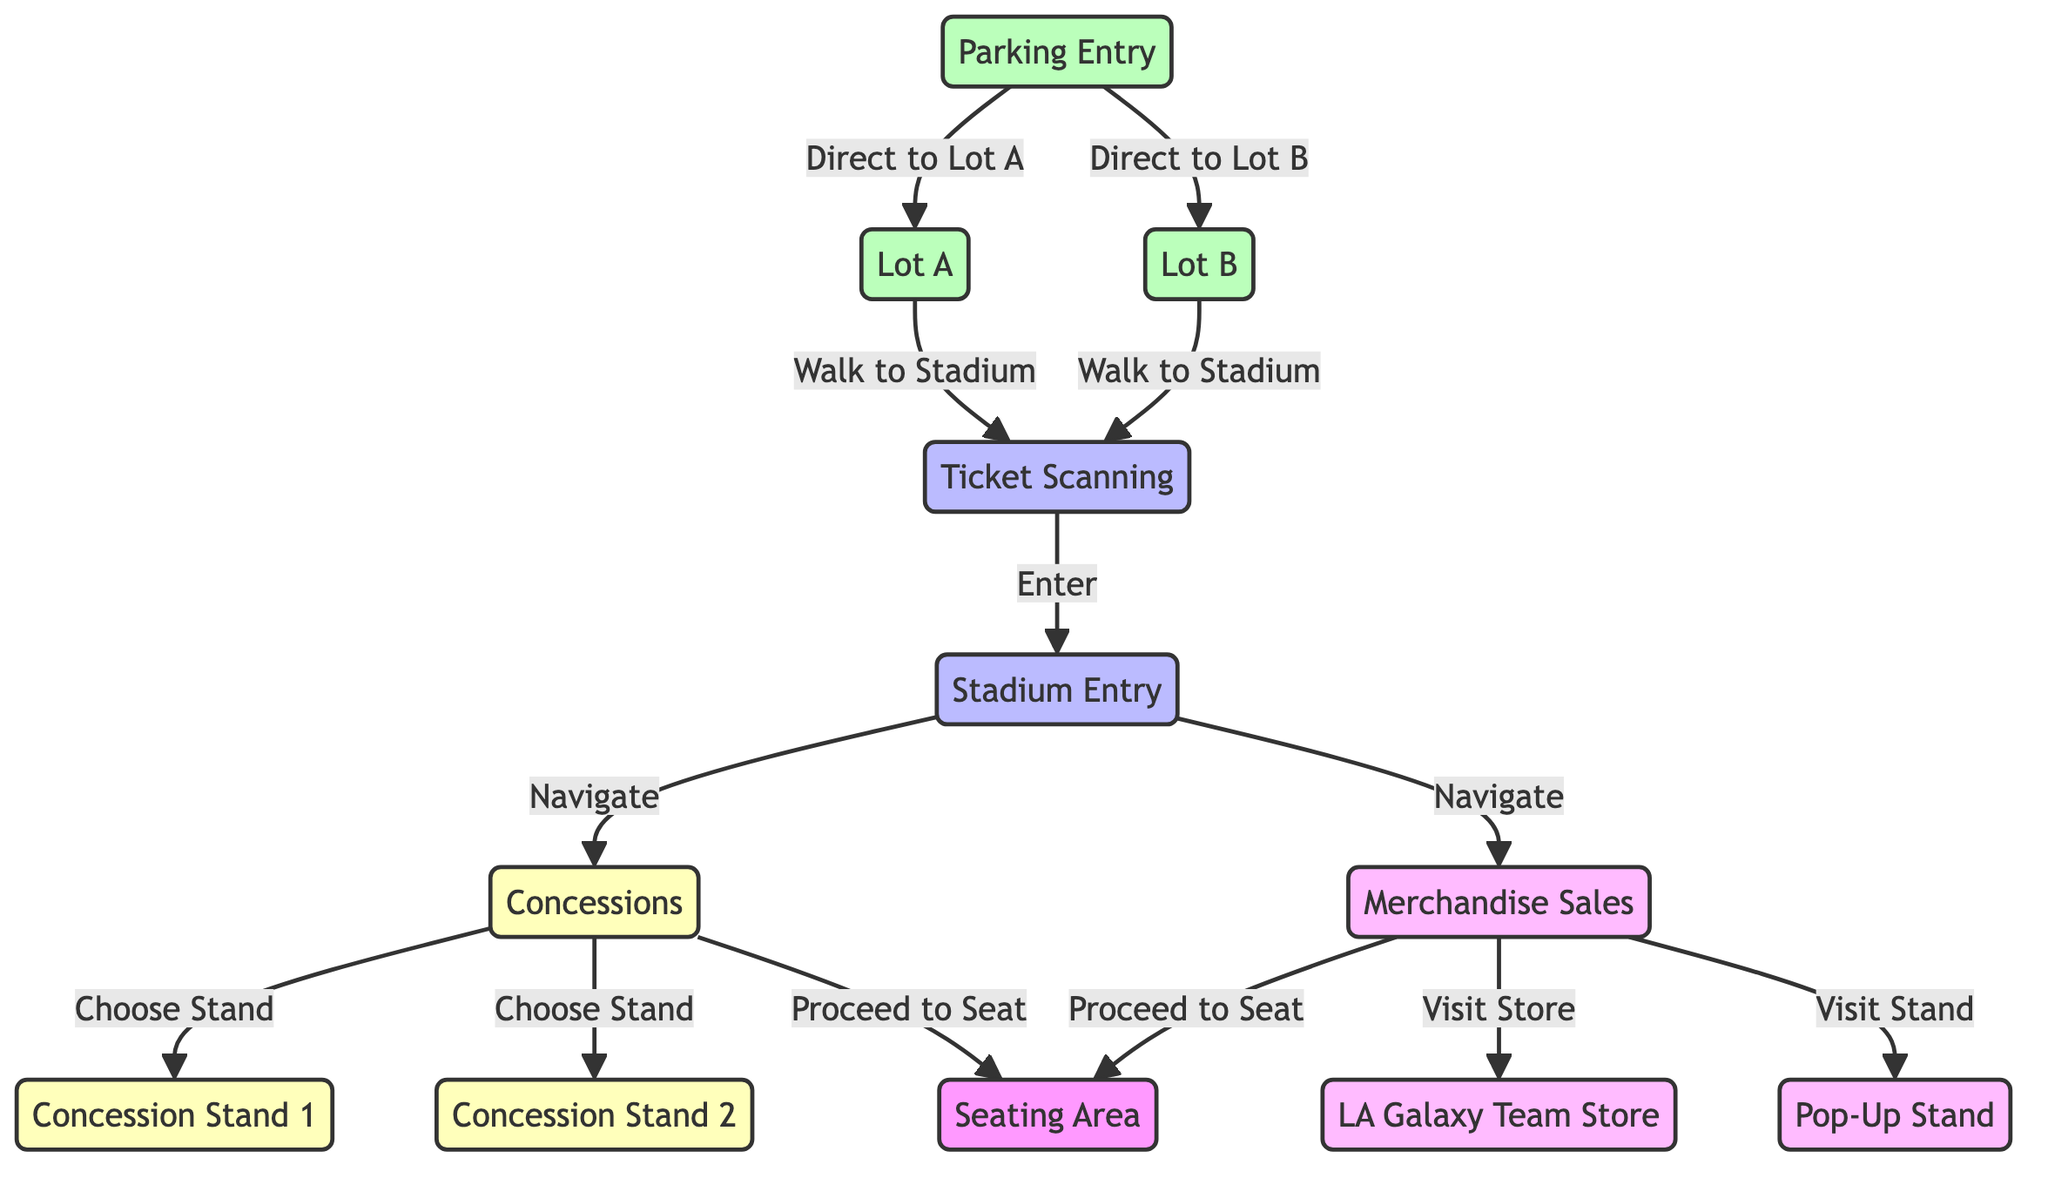What are the two parking lot options? The diagram shows that there are two parking lot options: Lot A and Lot B. These options directly follow the Parking Entry node, indicating where fans can park.
Answer: Lot A and Lot B How many concession stands are available? The diagram includes two specific concession stands that fans can choose from: Concession Stand 1 and Concession Stand 2. This information is indicated under the concessions node.
Answer: 2 What is the path from Lot A to the seating area? From Lot A, the path leads to Ticket Scanning, then to Stadium Entry, which navigates to Concessions, and finally proceeds to the Seating Area. This sequential connection describes how fans move from parking to seating.
Answer: Lot A → Ticket Scanning → Stadium Entry → Concessions → Seating Area Which merchandise store is directly connected to the merchandise sales node? The diagram directly indicates that the LA Galaxy Team Store is connected to the merchandise sales node, showing it as a specific destination for fans.
Answer: LA Galaxy Team Store What navigation option does a fan have upon entering the stadium? Upon entering the stadium, fans can navigate to either the concessions node or the merchandise sales node, which illustrates their options after ticket scanning.
Answer: Concessions and Merchandise Sales How many total nodes are connected to the concessions node? The concessions node connects to three distinct paths: two leads to the concession stands (Concession Stand 1 and Concession Stand 2) and one leads directly to the seating area, totaling three connections.
Answer: 3 What is the last action a fan takes after visiting the merchandise store? After visiting either the LA Galaxy Team Store or the Pop-Up Stand, the last action for a fan is to proceed to the seating area. This indicates the flow from merchandise to seating.
Answer: Proceed to Seat What distinguishes the two merchandise sales options? The two merchandise sales options are distinguished by their locations: one is the LA Galaxy Team Store, and the other is a Pop-Up Stand, representing different types of merchandise sales venues.
Answer: LA Galaxy Team Store and Pop-Up Stand 